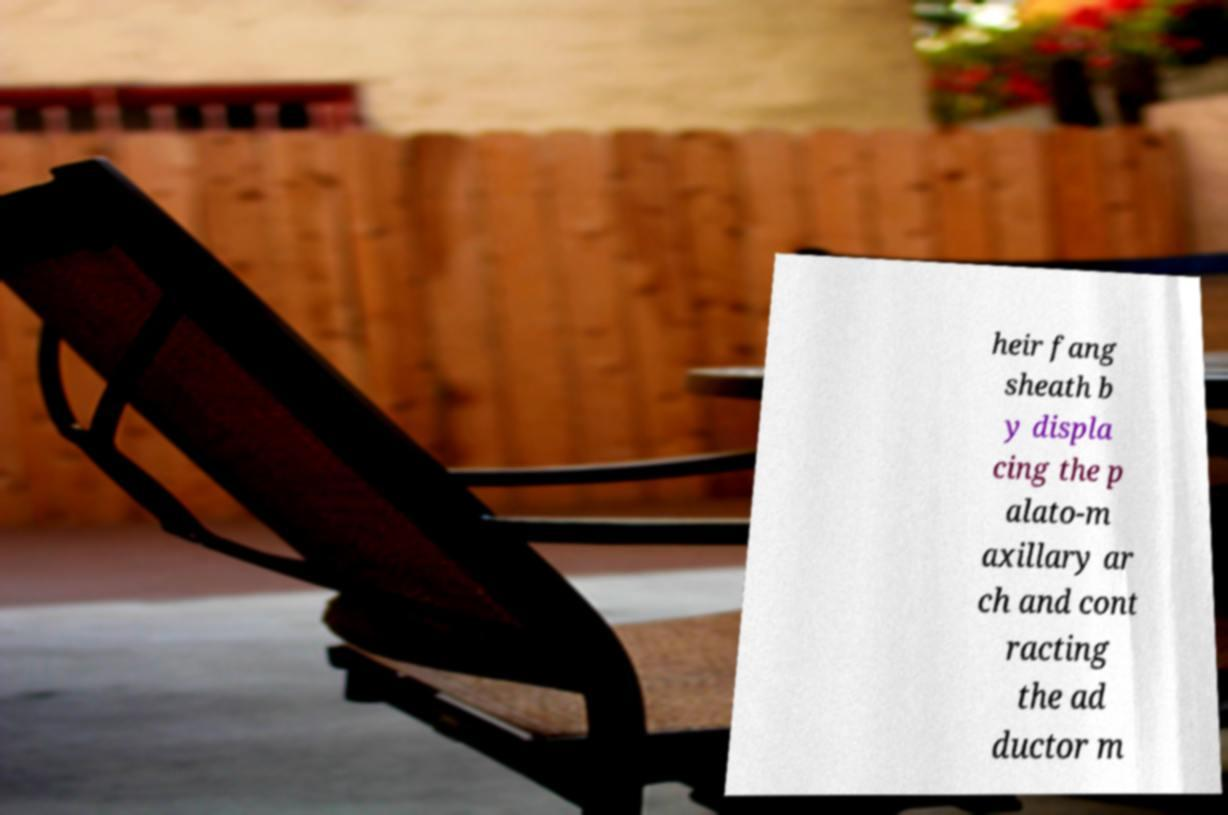Please read and relay the text visible in this image. What does it say? heir fang sheath b y displa cing the p alato-m axillary ar ch and cont racting the ad ductor m 